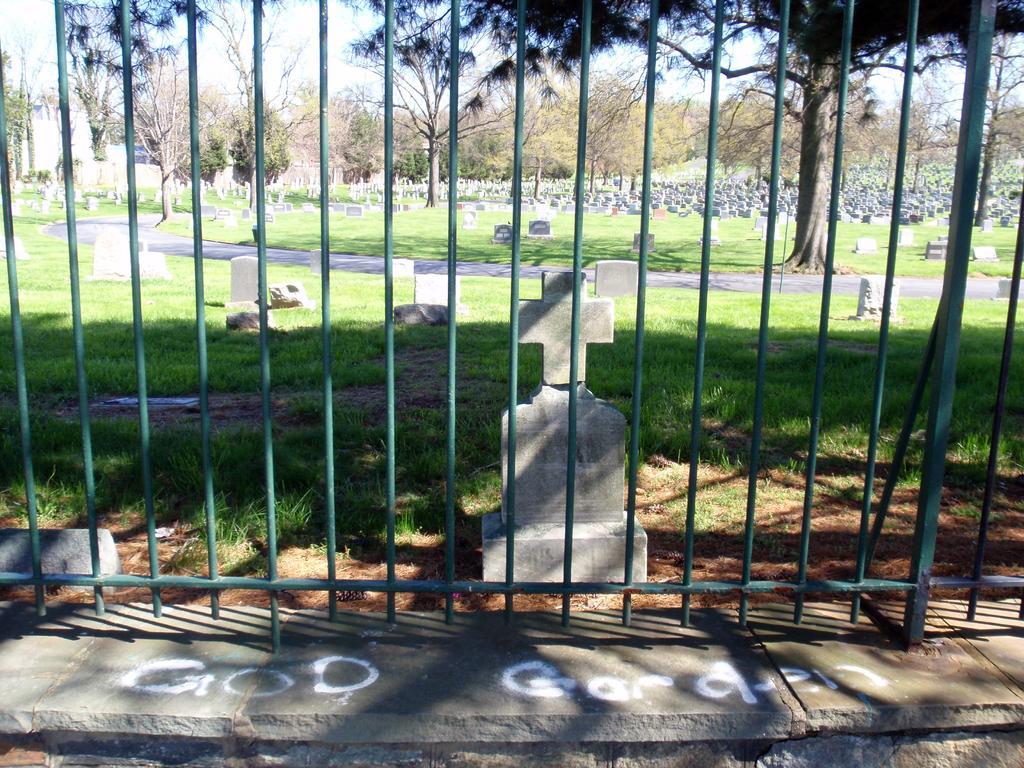In one or two sentences, can you explain what this image depicts? In this image we can see a graveyard, trees and sky through the iron grills. 